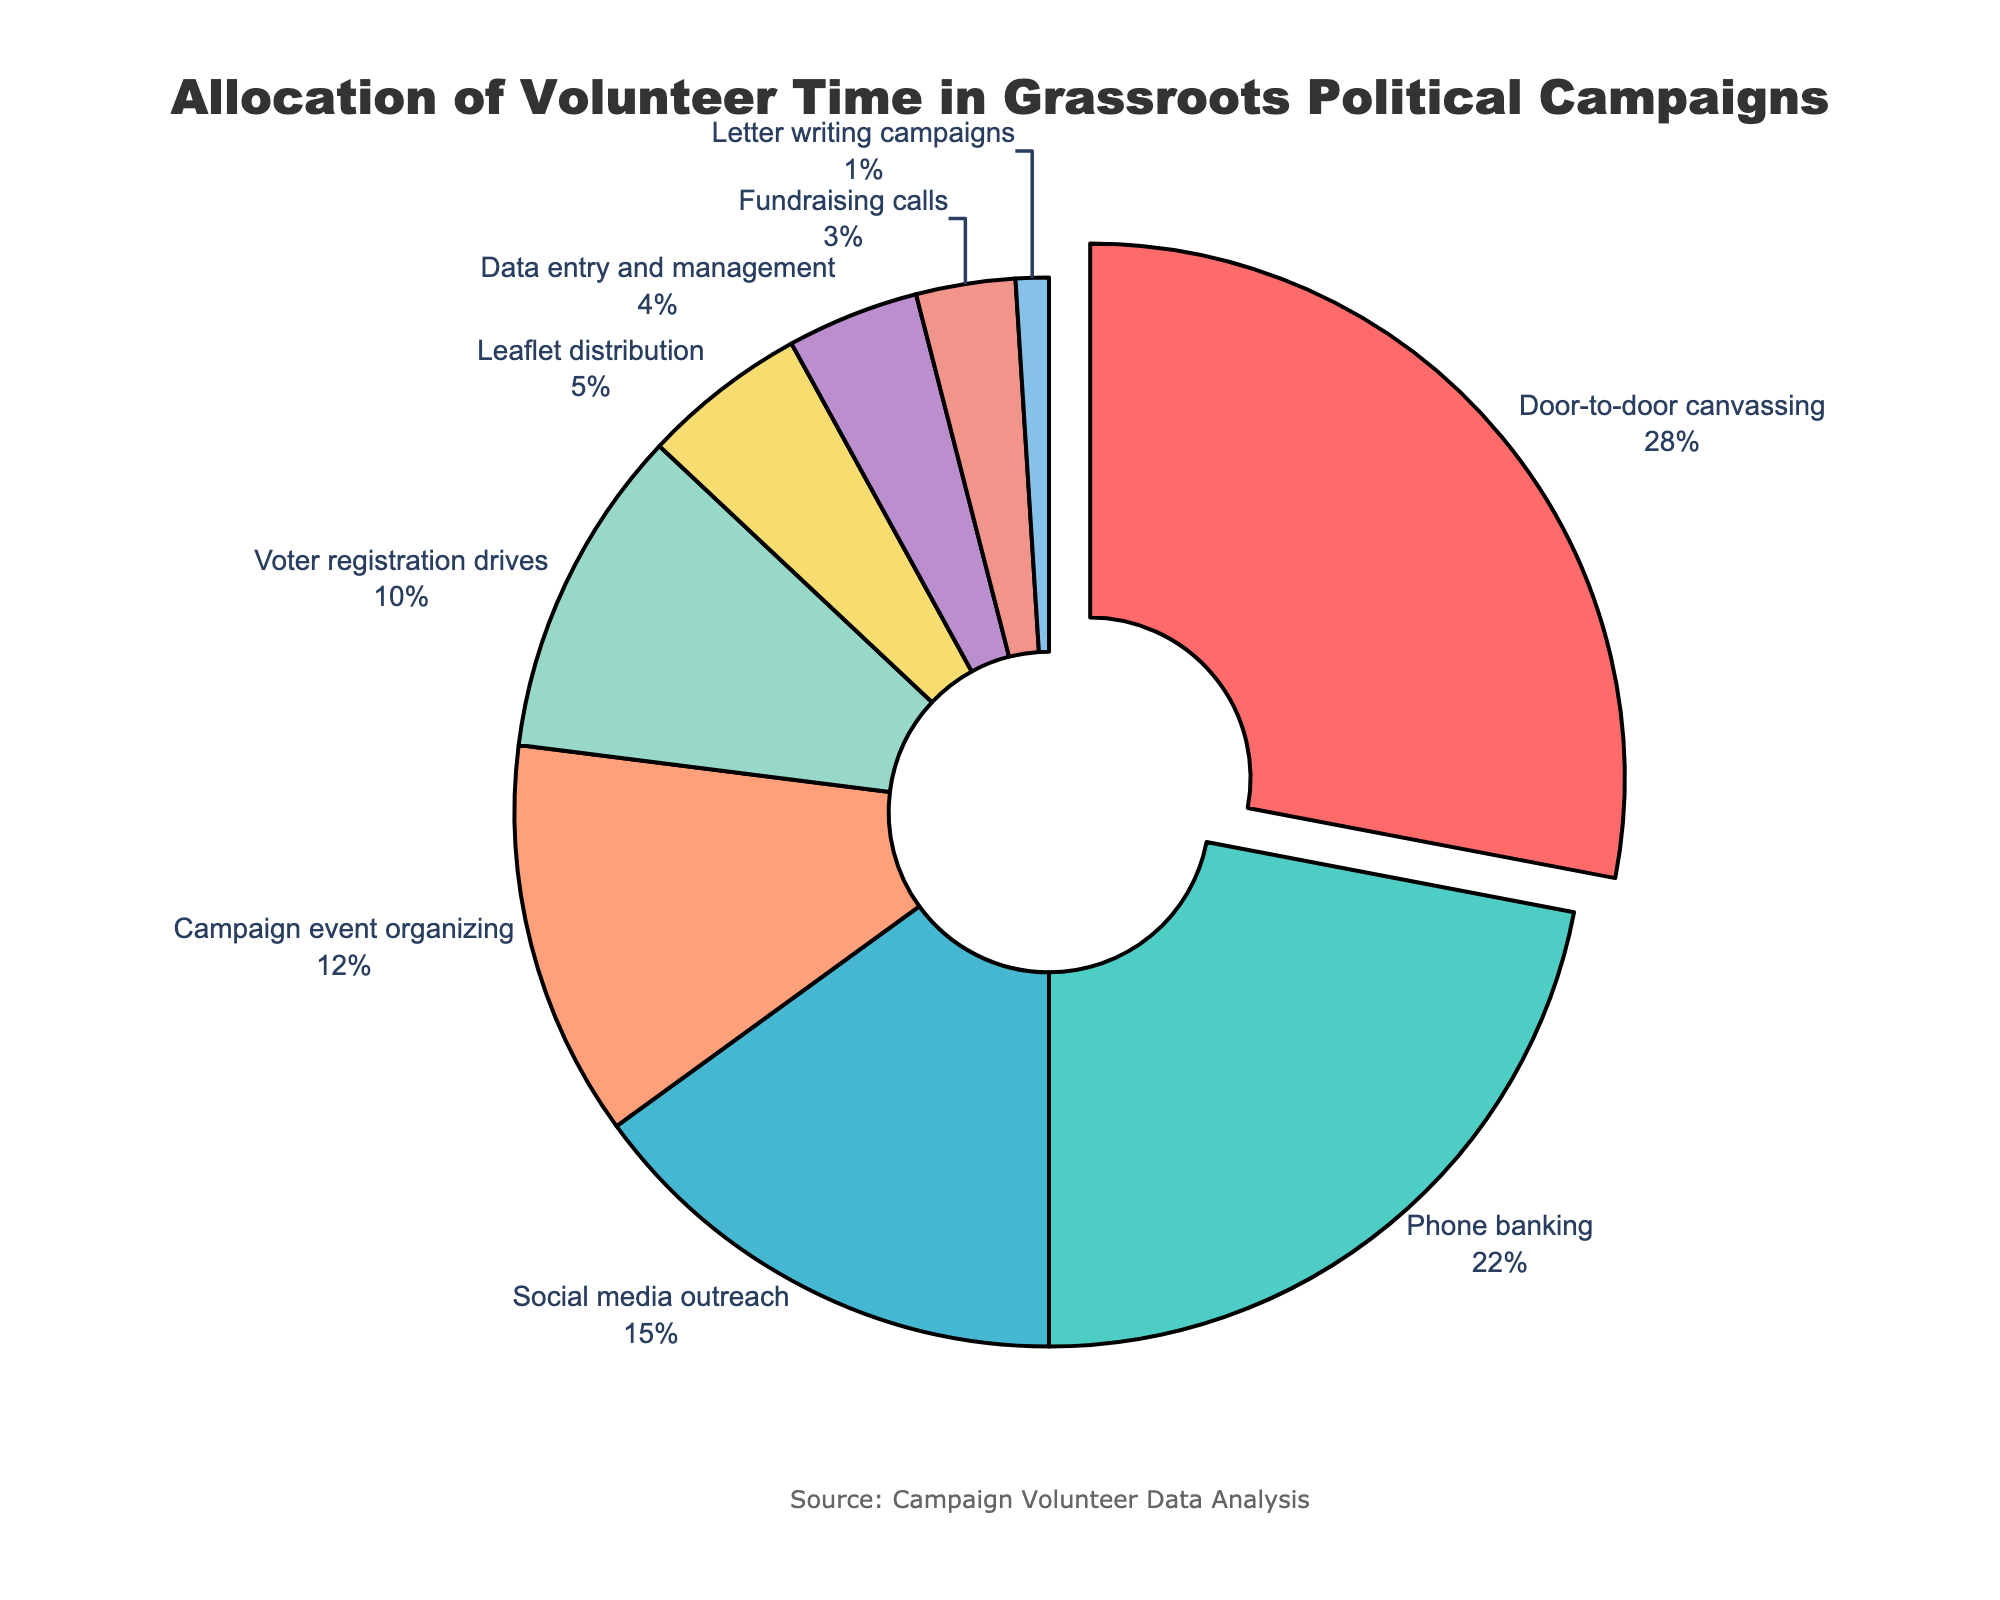What percentage of volunteer time is allocated to door-to-door canvassing and phone banking combined? Door-to-door canvassing accounts for 28%, and phone banking accounts for 22%. Adding these two percentages together gives 28% + 22% = 50%.
Answer: 50% Which activity has the smallest allocation of volunteer time? The activity with the smallest allocation of volunteer time is letter writing campaigns, which has a share of 1%.
Answer: Letter writing campaigns How much more volunteer time is allocated to door-to-door canvassing compared to leaflet distribution? Door-to-door canvassing has 28% of the volunteer time, while leaflet distribution has 5%. The difference is 28% - 5% = 23%.
Answer: 23% Compare the combined allocation of social media outreach and campaign event organizing to voter registration drives. Which is larger and by how much? Social media outreach accounts for 15%, and campaign event organizing accounts for 12%. Their combined allocation is 15% + 12% = 27%. Voter registration drives have a 10% allocation. The difference is 27% - 10% = 17%.
Answer: Social media outreach + campaign event organizing by 17% What percentage of volunteer time is allocated to activities other than door-to-door canvassing, phone banking, and social media outreach? Door-to-door canvassing, phone banking, and social media outreach together account for 28% + 22% + 15% = 65%. The percentage allocated to other activities is 100% - 65% = 35%.
Answer: 35% What is the color associated with the fundraising calls segment in the pie chart? The color associated with fundraising calls is red.
Answer: Red 